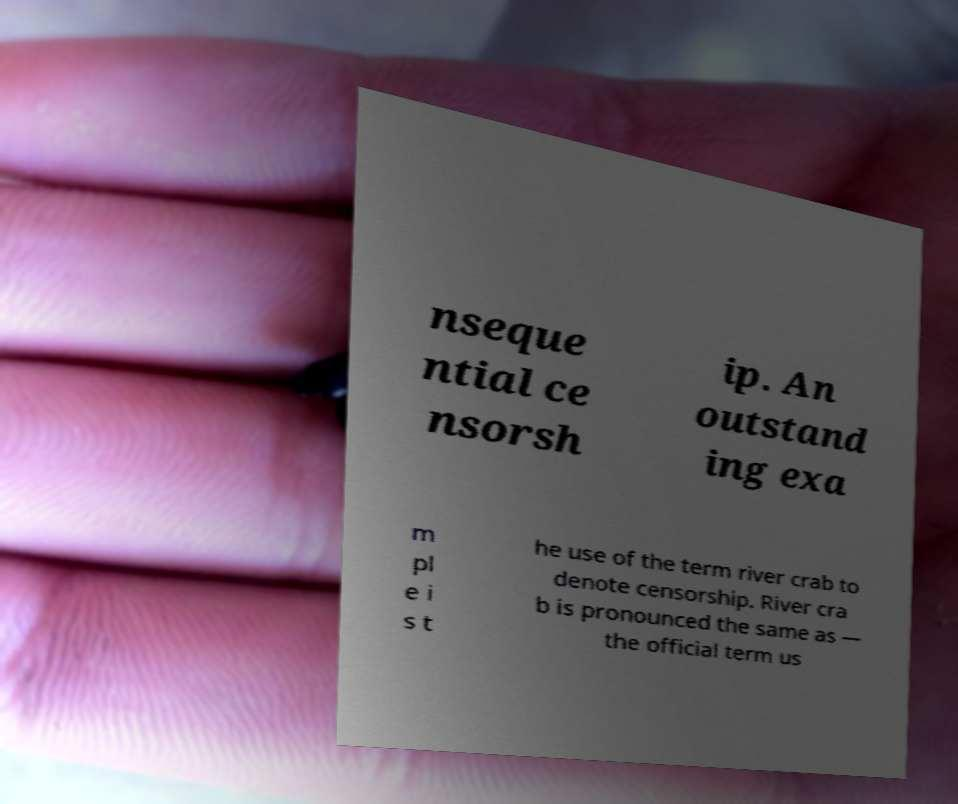What messages or text are displayed in this image? I need them in a readable, typed format. nseque ntial ce nsorsh ip. An outstand ing exa m pl e i s t he use of the term river crab to denote censorship. River cra b is pronounced the same as — the official term us 